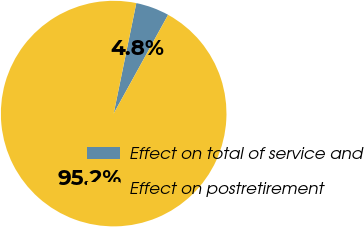Convert chart. <chart><loc_0><loc_0><loc_500><loc_500><pie_chart><fcel>Effect on total of service and<fcel>Effect on postretirement<nl><fcel>4.8%<fcel>95.2%<nl></chart> 